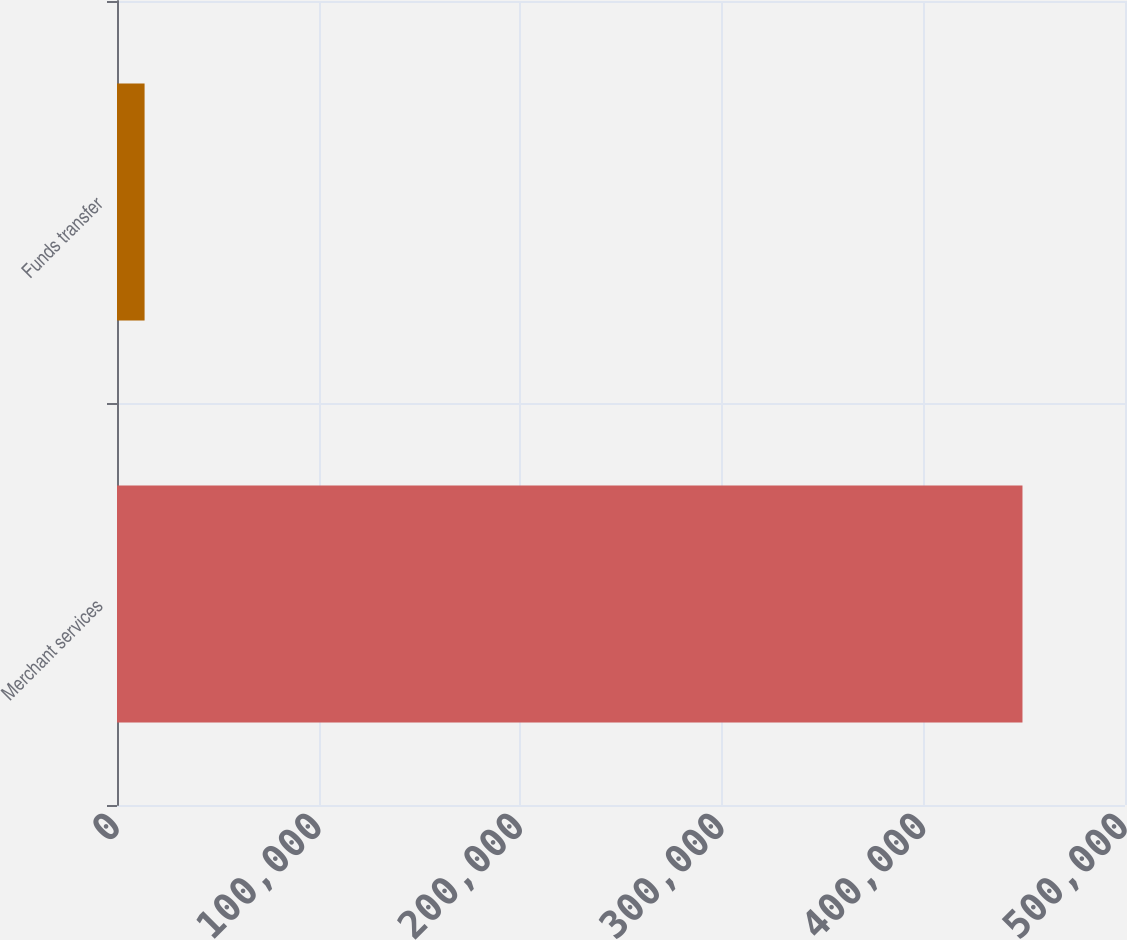<chart> <loc_0><loc_0><loc_500><loc_500><bar_chart><fcel>Merchant services<fcel>Funds transfer<nl><fcel>449144<fcel>13682<nl></chart> 